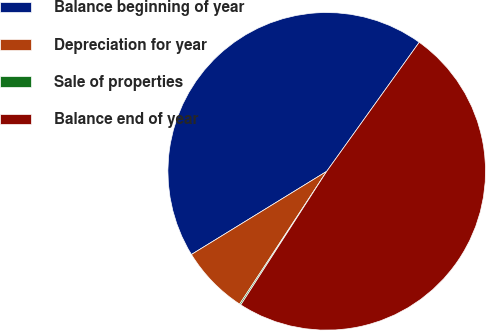Convert chart to OTSL. <chart><loc_0><loc_0><loc_500><loc_500><pie_chart><fcel>Balance beginning of year<fcel>Depreciation for year<fcel>Sale of properties<fcel>Balance end of year<nl><fcel>43.67%<fcel>6.99%<fcel>0.14%<fcel>49.2%<nl></chart> 